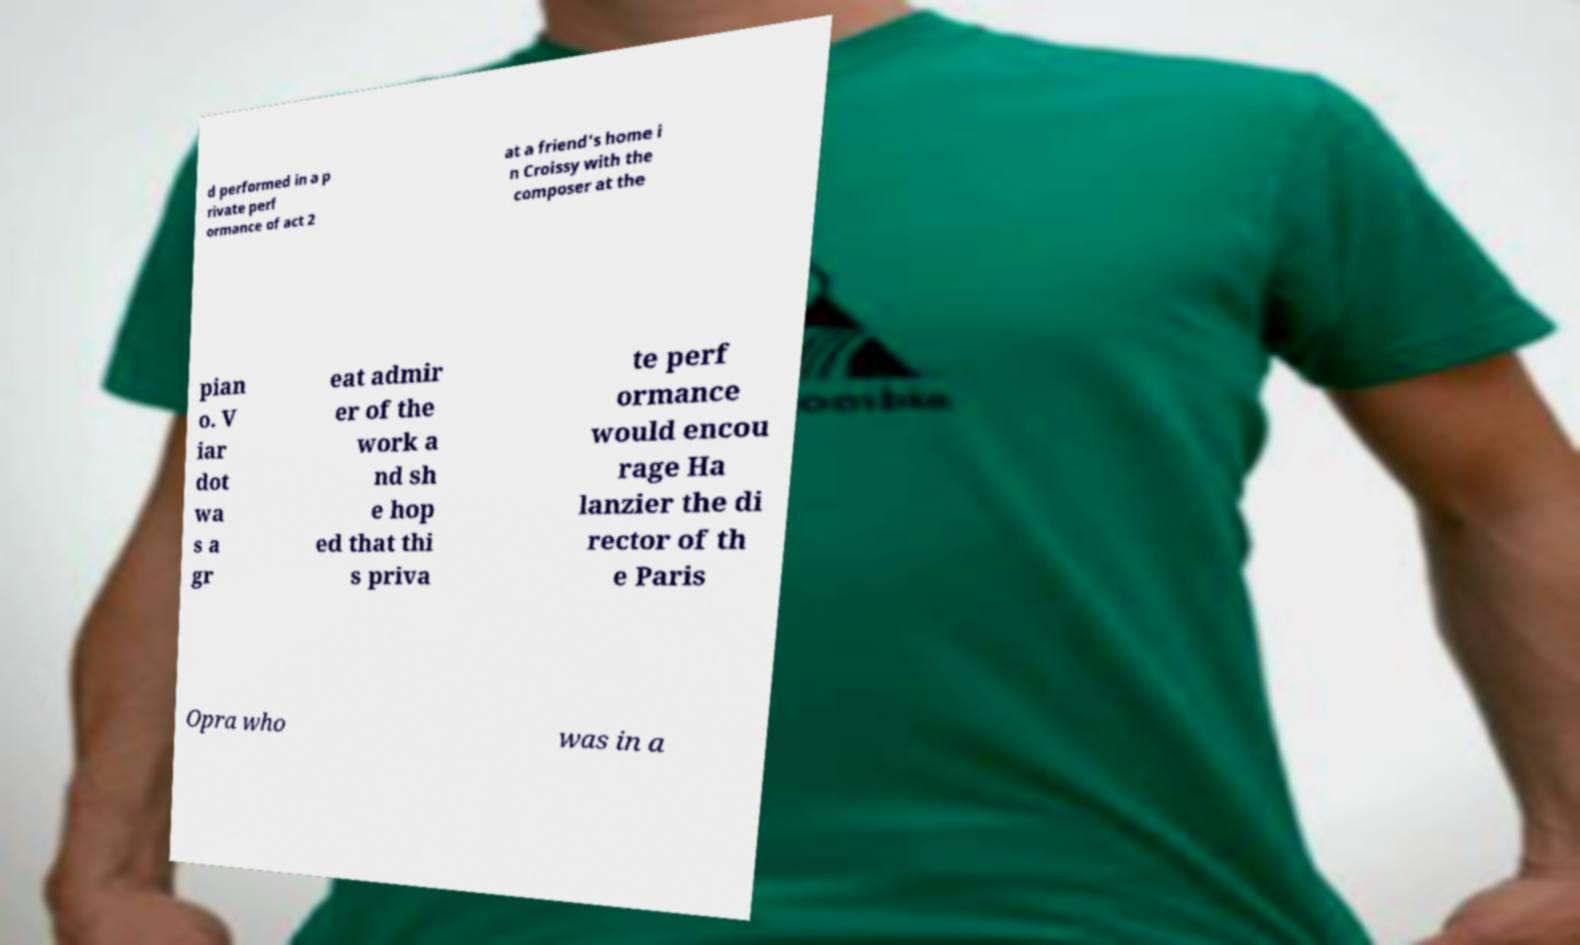Please read and relay the text visible in this image. What does it say? d performed in a p rivate perf ormance of act 2 at a friend's home i n Croissy with the composer at the pian o. V iar dot wa s a gr eat admir er of the work a nd sh e hop ed that thi s priva te perf ormance would encou rage Ha lanzier the di rector of th e Paris Opra who was in a 